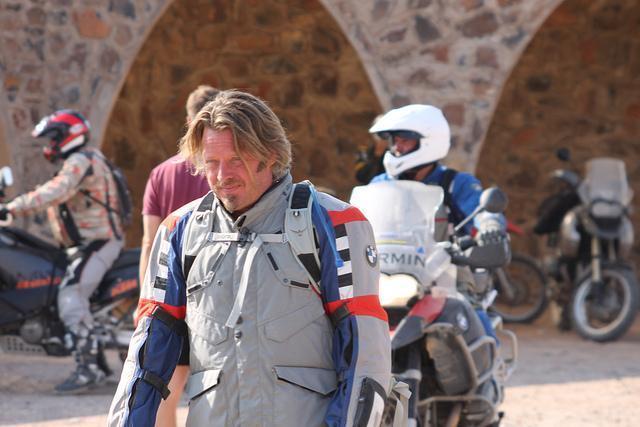How many motorcycles are in the photo?
Give a very brief answer. 4. How many people are in the photo?
Give a very brief answer. 4. 